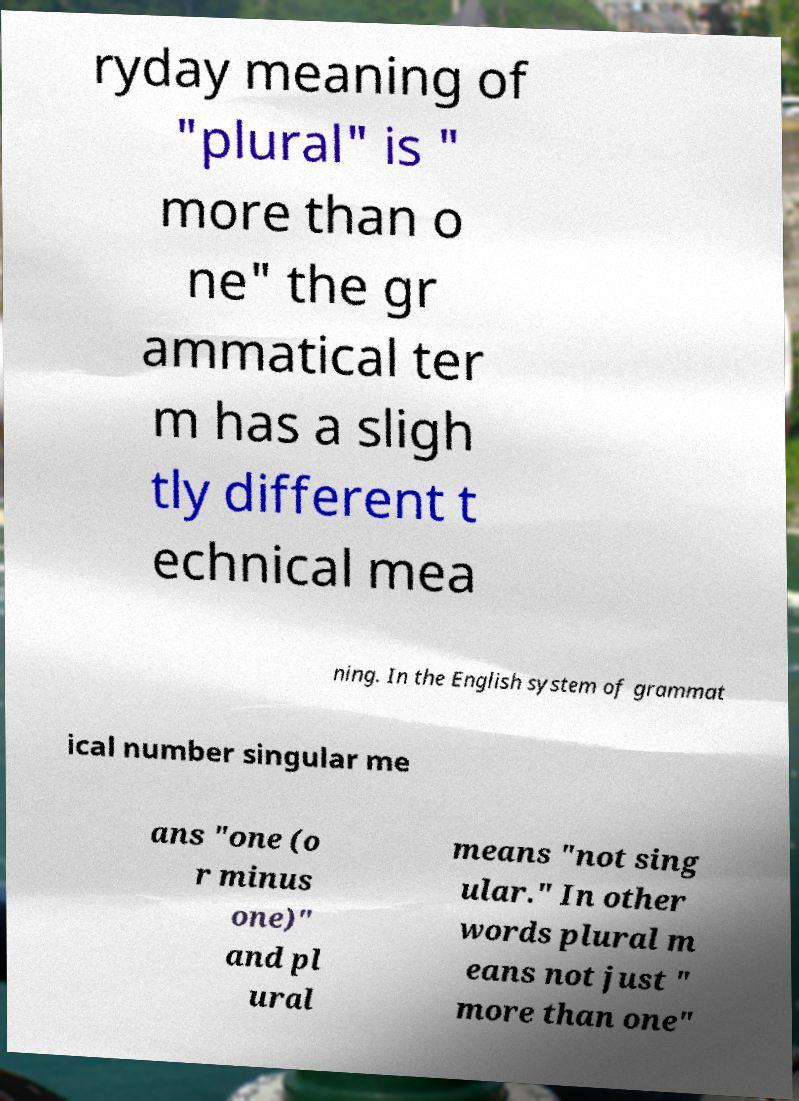For documentation purposes, I need the text within this image transcribed. Could you provide that? ryday meaning of "plural" is " more than o ne" the gr ammatical ter m has a sligh tly different t echnical mea ning. In the English system of grammat ical number singular me ans "one (o r minus one)" and pl ural means "not sing ular." In other words plural m eans not just " more than one" 